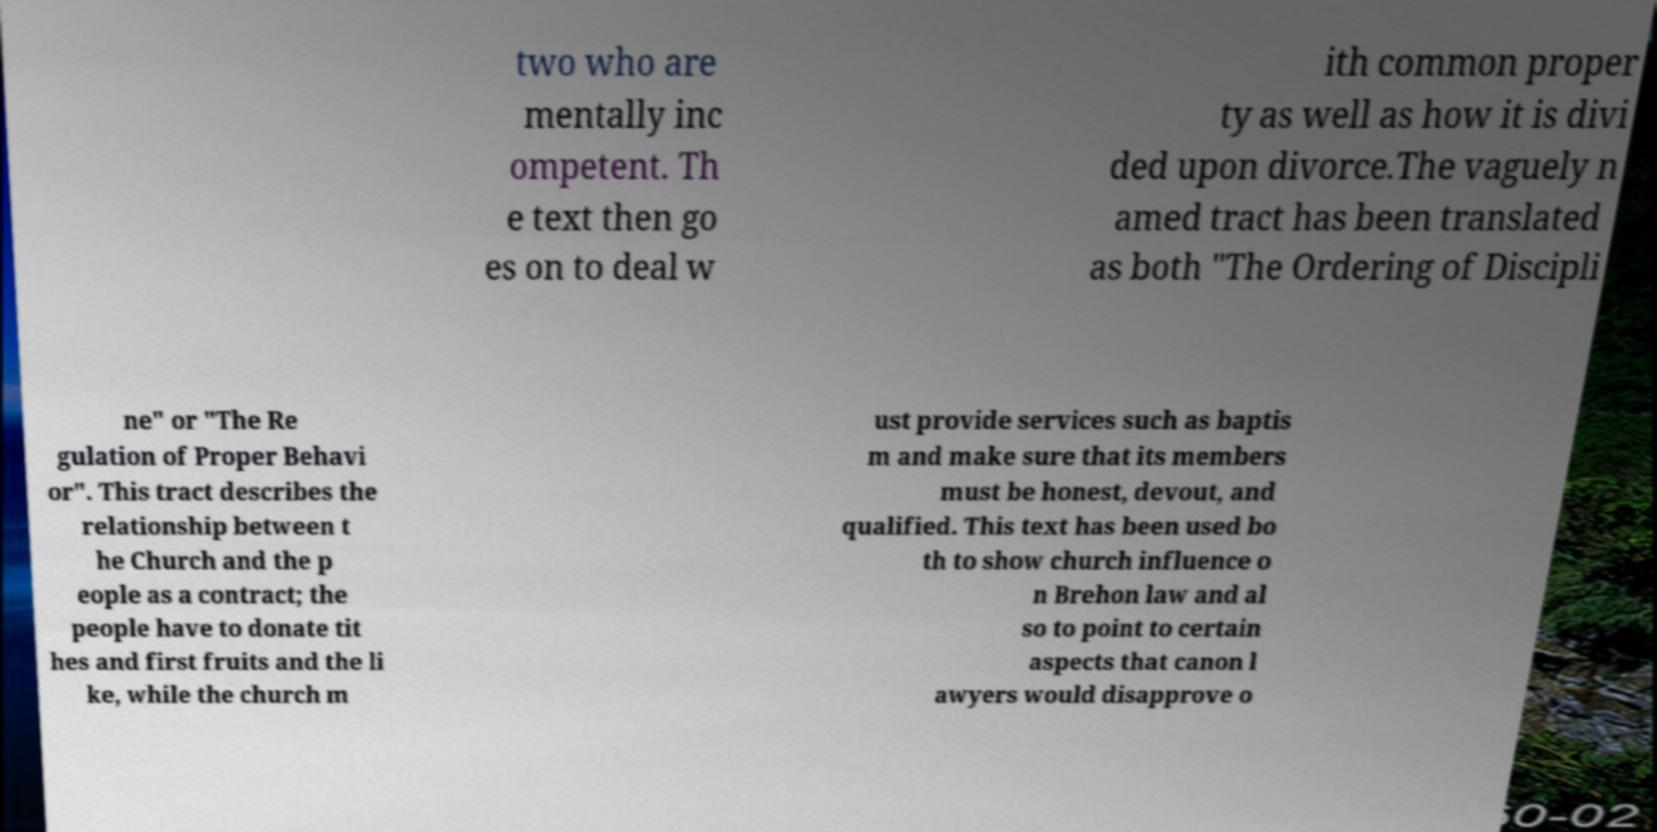What messages or text are displayed in this image? I need them in a readable, typed format. two who are mentally inc ompetent. Th e text then go es on to deal w ith common proper ty as well as how it is divi ded upon divorce.The vaguely n amed tract has been translated as both "The Ordering of Discipli ne" or "The Re gulation of Proper Behavi or". This tract describes the relationship between t he Church and the p eople as a contract; the people have to donate tit hes and first fruits and the li ke, while the church m ust provide services such as baptis m and make sure that its members must be honest, devout, and qualified. This text has been used bo th to show church influence o n Brehon law and al so to point to certain aspects that canon l awyers would disapprove o 